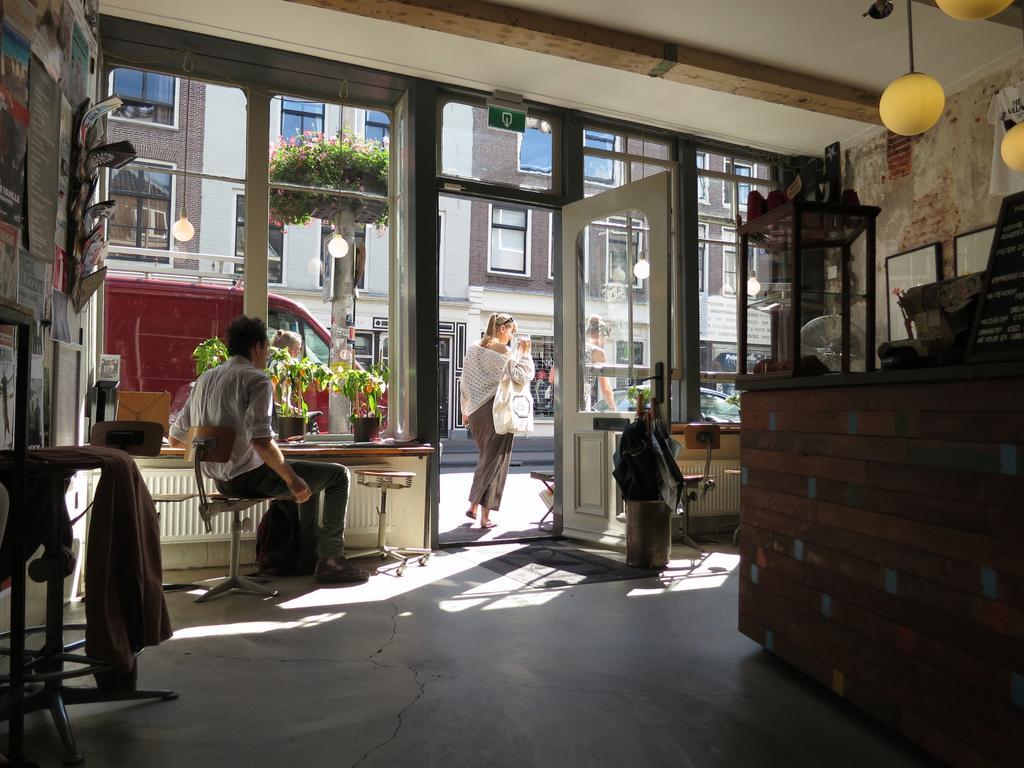How would you summarize this image in a sentence or two? In the given image we can see there are four person. This is a room man is sitting on a chair. This is a light bulb. The three of the are standing out of the house. This is a building and a tree. 